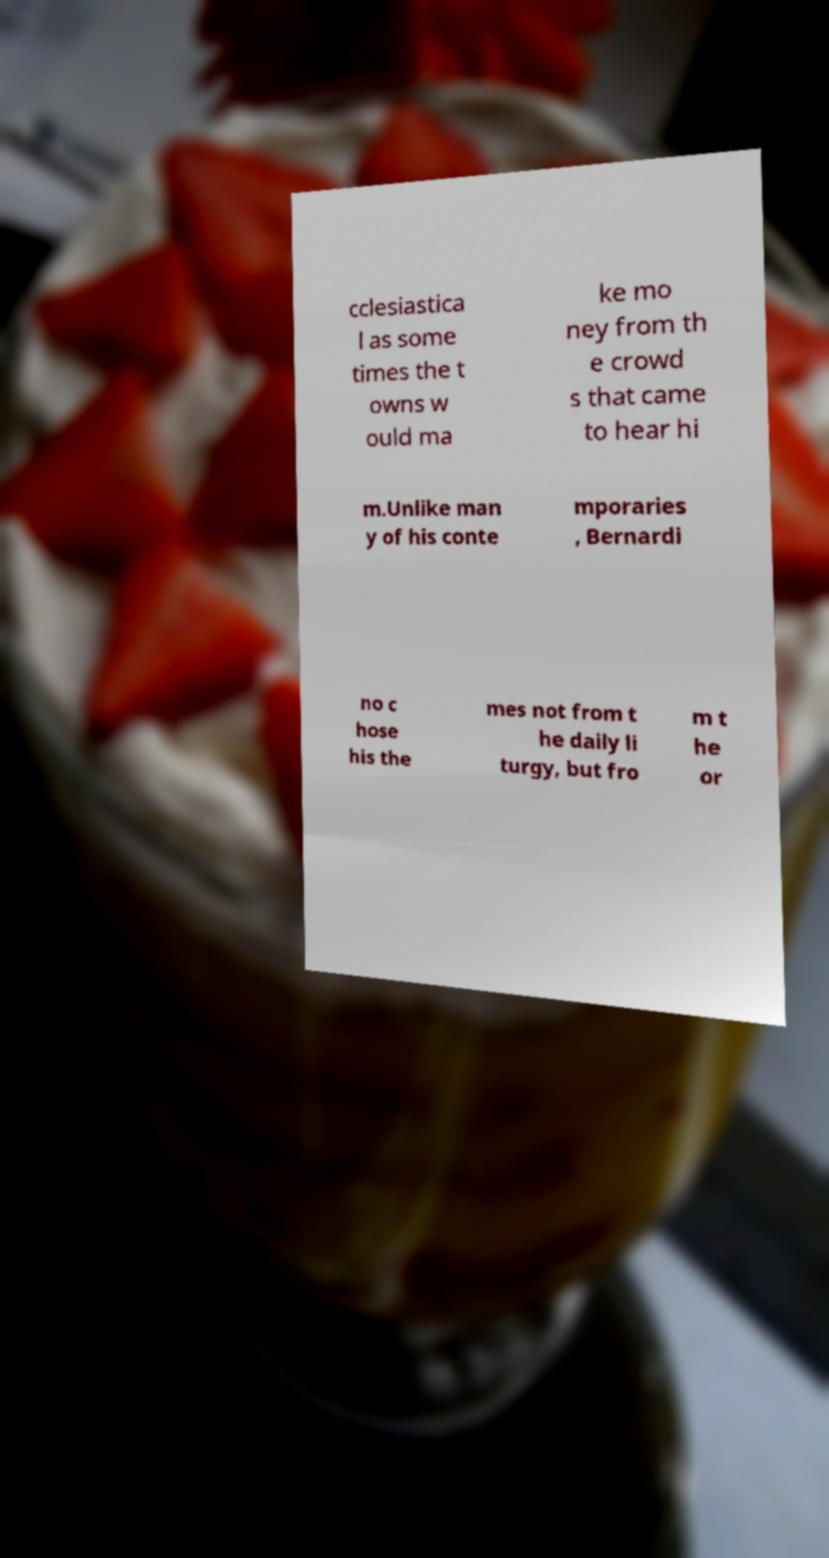Can you read and provide the text displayed in the image?This photo seems to have some interesting text. Can you extract and type it out for me? cclesiastica l as some times the t owns w ould ma ke mo ney from th e crowd s that came to hear hi m.Unlike man y of his conte mporaries , Bernardi no c hose his the mes not from t he daily li turgy, but fro m t he or 